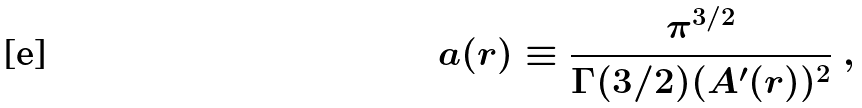<formula> <loc_0><loc_0><loc_500><loc_500>a ( r ) \equiv \frac { \pi ^ { 3 / 2 } } { \Gamma ( 3 / 2 ) ( A ^ { \prime } ( r ) ) ^ { 2 } } \ ,</formula> 